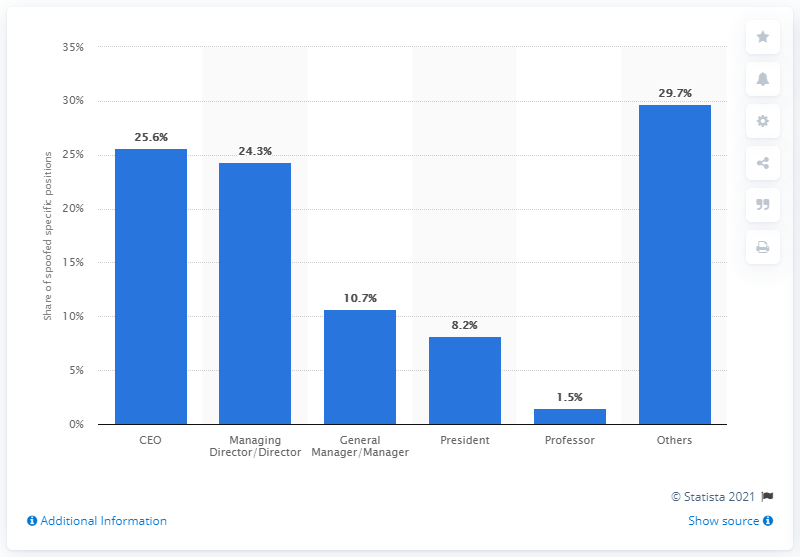What's the percentage of BEC scams involving the impersonation of a president according to the chart? Based on the bar chart, 8.2% of BEC scams involve scammers pretending to be the president of the targeted company. 